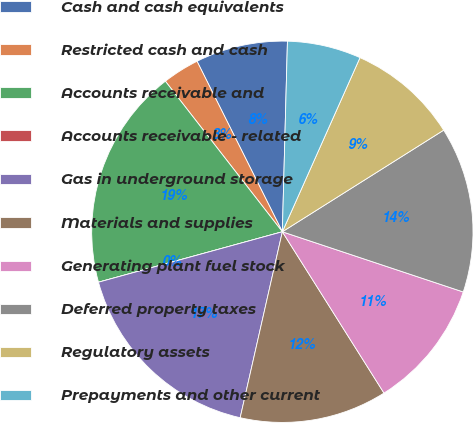Convert chart. <chart><loc_0><loc_0><loc_500><loc_500><pie_chart><fcel>Cash and cash equivalents<fcel>Restricted cash and cash<fcel>Accounts receivable and<fcel>Accounts receivable - related<fcel>Gas in underground storage<fcel>Materials and supplies<fcel>Generating plant fuel stock<fcel>Deferred property taxes<fcel>Regulatory assets<fcel>Prepayments and other current<nl><fcel>7.81%<fcel>3.13%<fcel>18.75%<fcel>0.0%<fcel>17.19%<fcel>12.5%<fcel>10.94%<fcel>14.06%<fcel>9.38%<fcel>6.25%<nl></chart> 